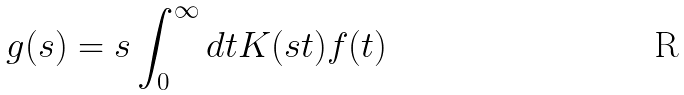<formula> <loc_0><loc_0><loc_500><loc_500>g ( s ) = s \int _ { 0 } ^ { \infty } d t K ( s t ) f ( t )</formula> 